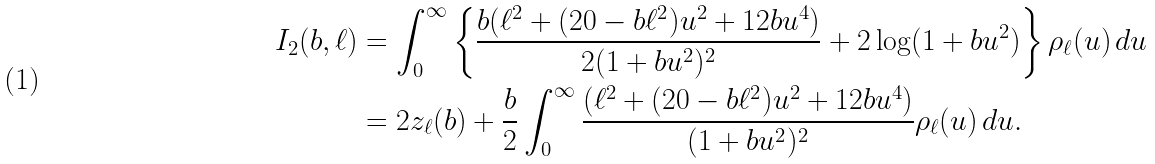<formula> <loc_0><loc_0><loc_500><loc_500>I _ { 2 } ( b , \ell ) & = \int _ { 0 } ^ { \infty } \left \{ \frac { b ( \ell ^ { 2 } + ( 2 0 - b \ell ^ { 2 } ) u ^ { 2 } + 1 2 b u ^ { 4 } ) } { 2 ( 1 + b u ^ { 2 } ) ^ { 2 } } + 2 \log ( 1 + b u ^ { 2 } ) \right \} \rho _ { \ell } ( u ) \, d u \\ & = 2 z _ { \ell } ( b ) + \frac { b } { 2 } \int _ { 0 } ^ { \infty } \frac { ( \ell ^ { 2 } + ( 2 0 - b \ell ^ { 2 } ) u ^ { 2 } + 1 2 b u ^ { 4 } ) } { ( 1 + b u ^ { 2 } ) ^ { 2 } } \rho _ { \ell } ( u ) \, d u .</formula> 